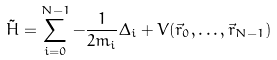<formula> <loc_0><loc_0><loc_500><loc_500>\tilde { H } = \sum _ { i = 0 } ^ { N - 1 } - \frac { 1 } { 2 m _ { i } } \Delta _ { i } + V ( \vec { r } _ { 0 } , \dots , \vec { r } _ { N - 1 } )</formula> 